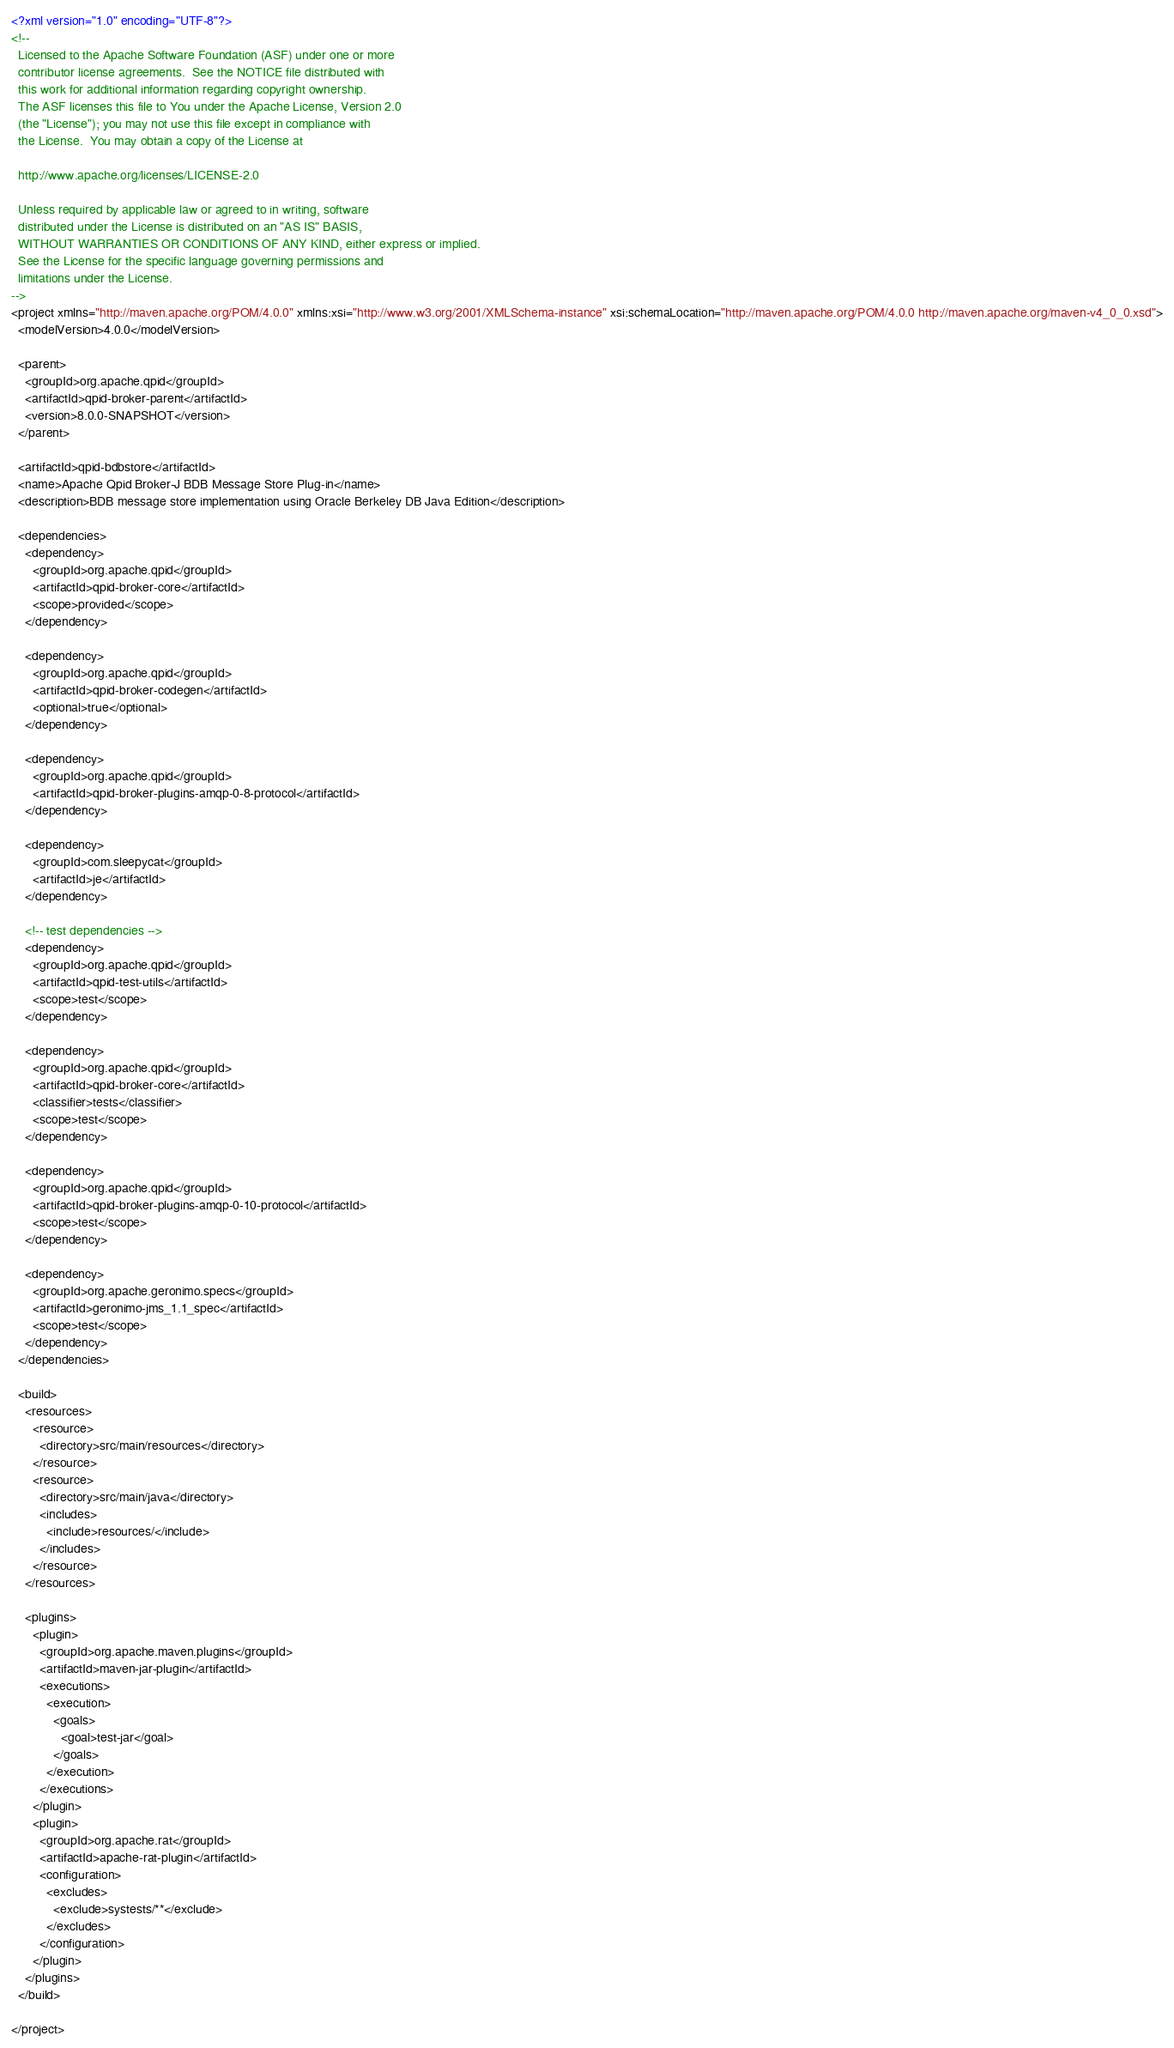Convert code to text. <code><loc_0><loc_0><loc_500><loc_500><_XML_><?xml version="1.0" encoding="UTF-8"?>
<!--
  Licensed to the Apache Software Foundation (ASF) under one or more
  contributor license agreements.  See the NOTICE file distributed with
  this work for additional information regarding copyright ownership.
  The ASF licenses this file to You under the Apache License, Version 2.0
  (the "License"); you may not use this file except in compliance with
  the License.  You may obtain a copy of the License at
  
  http://www.apache.org/licenses/LICENSE-2.0
  
  Unless required by applicable law or agreed to in writing, software
  distributed under the License is distributed on an "AS IS" BASIS,
  WITHOUT WARRANTIES OR CONDITIONS OF ANY KIND, either express or implied.
  See the License for the specific language governing permissions and
  limitations under the License.
-->
<project xmlns="http://maven.apache.org/POM/4.0.0" xmlns:xsi="http://www.w3.org/2001/XMLSchema-instance" xsi:schemaLocation="http://maven.apache.org/POM/4.0.0 http://maven.apache.org/maven-v4_0_0.xsd">
  <modelVersion>4.0.0</modelVersion>

  <parent>
    <groupId>org.apache.qpid</groupId>
    <artifactId>qpid-broker-parent</artifactId>
    <version>8.0.0-SNAPSHOT</version>
  </parent>

  <artifactId>qpid-bdbstore</artifactId>
  <name>Apache Qpid Broker-J BDB Message Store Plug-in</name>
  <description>BDB message store implementation using Oracle Berkeley DB Java Edition</description>

  <dependencies>
    <dependency>
      <groupId>org.apache.qpid</groupId>
      <artifactId>qpid-broker-core</artifactId>
      <scope>provided</scope>
    </dependency>

    <dependency>
      <groupId>org.apache.qpid</groupId>
      <artifactId>qpid-broker-codegen</artifactId>
      <optional>true</optional>
    </dependency>

    <dependency>
      <groupId>org.apache.qpid</groupId>
      <artifactId>qpid-broker-plugins-amqp-0-8-protocol</artifactId>
    </dependency>

    <dependency>
      <groupId>com.sleepycat</groupId>
      <artifactId>je</artifactId>
    </dependency>

    <!-- test dependencies -->
    <dependency>
      <groupId>org.apache.qpid</groupId>
      <artifactId>qpid-test-utils</artifactId>
      <scope>test</scope>
    </dependency>

    <dependency>
      <groupId>org.apache.qpid</groupId>
      <artifactId>qpid-broker-core</artifactId>
      <classifier>tests</classifier>
      <scope>test</scope>
    </dependency>

    <dependency>
      <groupId>org.apache.qpid</groupId>
      <artifactId>qpid-broker-plugins-amqp-0-10-protocol</artifactId>
      <scope>test</scope>
    </dependency>

    <dependency>
      <groupId>org.apache.geronimo.specs</groupId>
      <artifactId>geronimo-jms_1.1_spec</artifactId>
      <scope>test</scope>
    </dependency>
  </dependencies>

  <build>
    <resources>
      <resource>
        <directory>src/main/resources</directory>
      </resource>
      <resource>
        <directory>src/main/java</directory>
        <includes>
          <include>resources/</include>
        </includes>
      </resource>
    </resources>

    <plugins>
      <plugin>
        <groupId>org.apache.maven.plugins</groupId>
        <artifactId>maven-jar-plugin</artifactId>
        <executions>
          <execution>
            <goals>
              <goal>test-jar</goal>
            </goals>
          </execution>
        </executions>
      </plugin>
      <plugin>
        <groupId>org.apache.rat</groupId>
        <artifactId>apache-rat-plugin</artifactId>
        <configuration>
          <excludes>
            <exclude>systests/**</exclude>
          </excludes>
        </configuration>
      </plugin>
    </plugins>
  </build>

</project>
</code> 